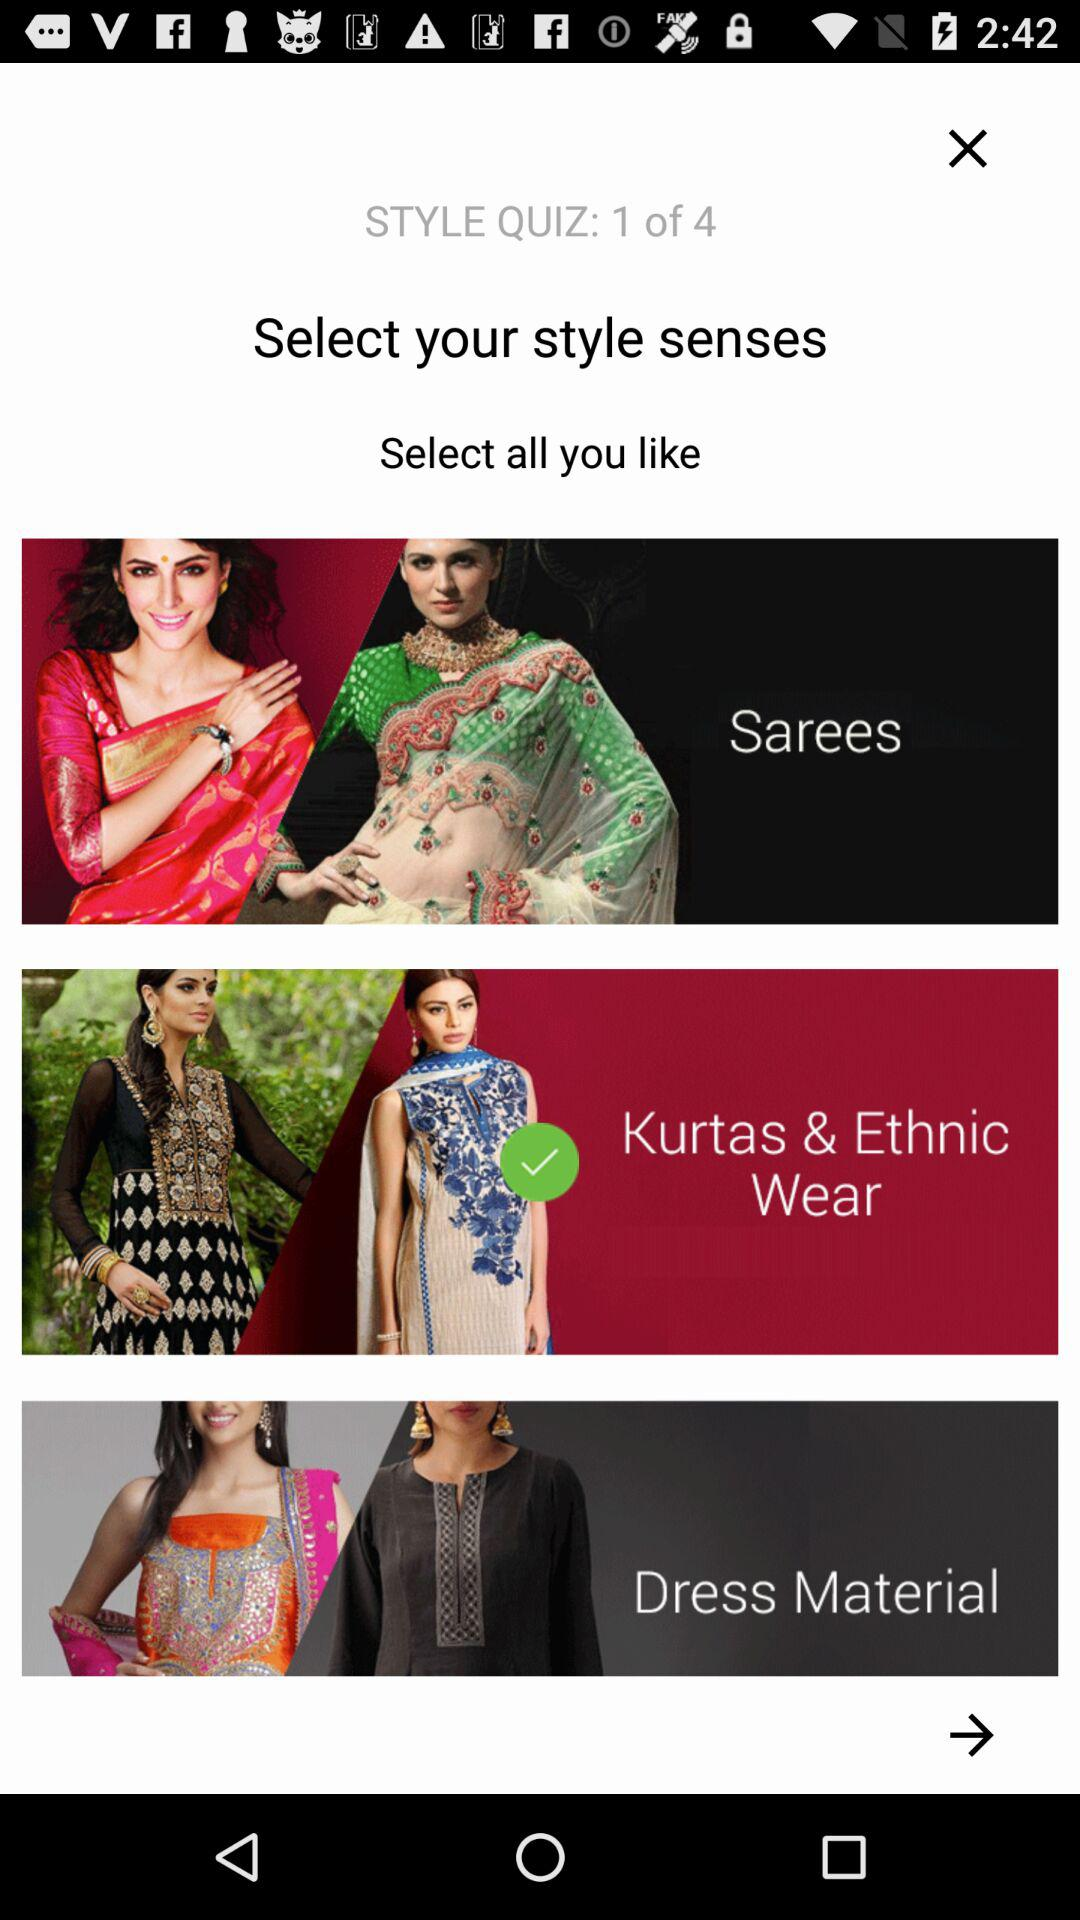How many items are in the quiz?
Answer the question using a single word or phrase. 3 